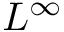<formula> <loc_0><loc_0><loc_500><loc_500>L ^ { \infty }</formula> 